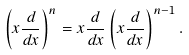Convert formula to latex. <formula><loc_0><loc_0><loc_500><loc_500>\left ( x \frac { d } { d x } \right ) ^ { n } = x \frac { d } { d x } \left ( x \frac { d } { d x } \right ) ^ { n - 1 } .</formula> 